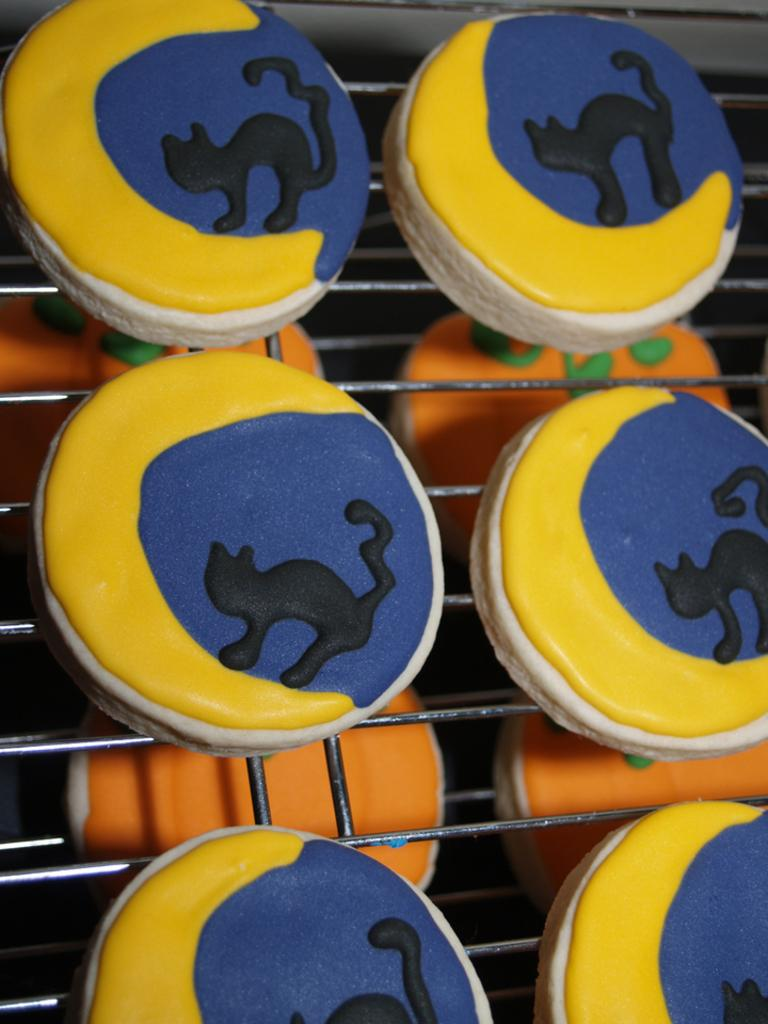What type of food can be seen in the image? There are cookies in the image. What colors are the cookies? The cookies are yellow and orange in color. Where are the cookies located in the image? The cookies are on a grill. What type of scale can be seen in the image? There is no scale present in the image. What riddle is depicted in the image? There is no riddle depicted in the image; it features cookies on a grill. 